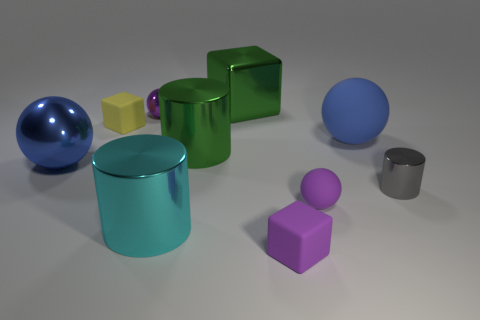Subtract all brown spheres. Subtract all green blocks. How many spheres are left? 4 Subtract all cylinders. How many objects are left? 7 Add 7 large shiny blocks. How many large shiny blocks exist? 8 Subtract 1 yellow cubes. How many objects are left? 9 Subtract all purple rubber objects. Subtract all cyan shiny objects. How many objects are left? 7 Add 6 large cyan metallic cylinders. How many large cyan metallic cylinders are left? 7 